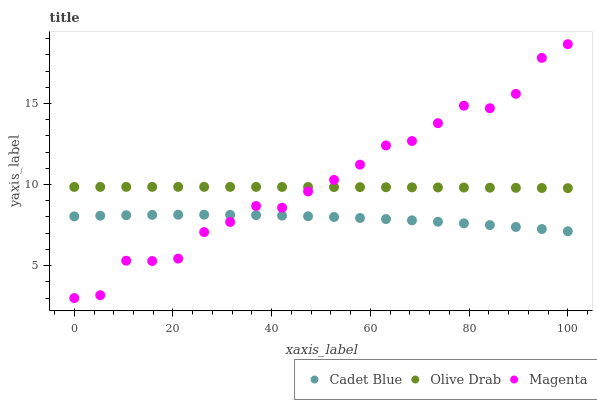Does Cadet Blue have the minimum area under the curve?
Answer yes or no. Yes. Does Magenta have the maximum area under the curve?
Answer yes or no. Yes. Does Olive Drab have the minimum area under the curve?
Answer yes or no. No. Does Olive Drab have the maximum area under the curve?
Answer yes or no. No. Is Olive Drab the smoothest?
Answer yes or no. Yes. Is Magenta the roughest?
Answer yes or no. Yes. Is Cadet Blue the smoothest?
Answer yes or no. No. Is Cadet Blue the roughest?
Answer yes or no. No. Does Magenta have the lowest value?
Answer yes or no. Yes. Does Cadet Blue have the lowest value?
Answer yes or no. No. Does Magenta have the highest value?
Answer yes or no. Yes. Does Olive Drab have the highest value?
Answer yes or no. No. Is Cadet Blue less than Olive Drab?
Answer yes or no. Yes. Is Olive Drab greater than Cadet Blue?
Answer yes or no. Yes. Does Magenta intersect Olive Drab?
Answer yes or no. Yes. Is Magenta less than Olive Drab?
Answer yes or no. No. Is Magenta greater than Olive Drab?
Answer yes or no. No. Does Cadet Blue intersect Olive Drab?
Answer yes or no. No. 